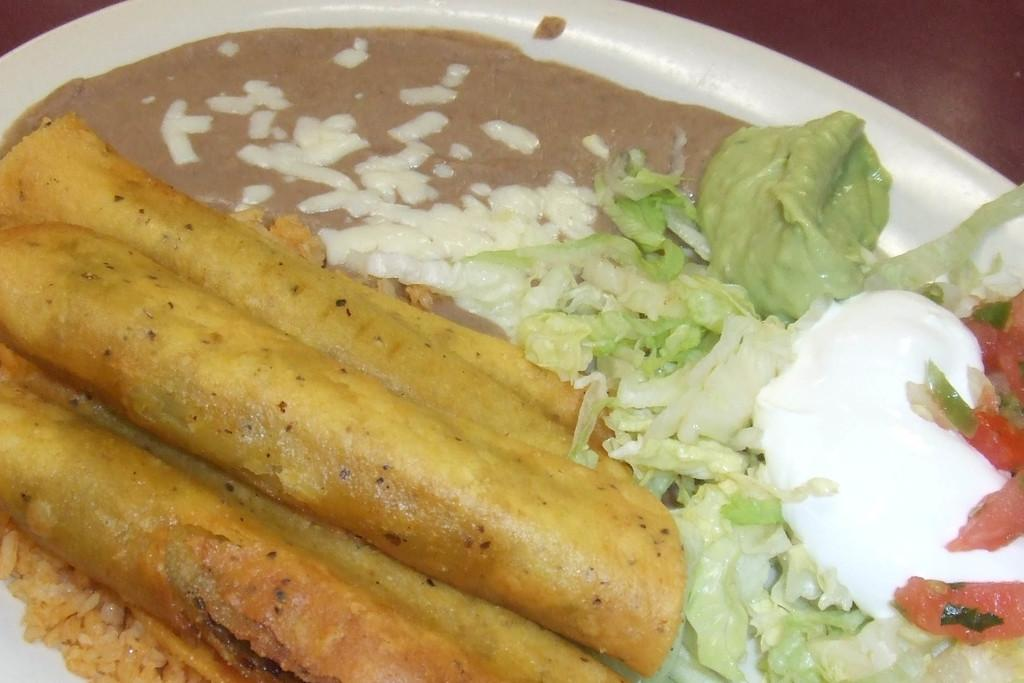What color is the plate that is visible in the image? There is a white color plate in the image. What type of food is on the plate? There is breakfast food, salads, and curry on the plate. What type of business is being conducted on the plate? There is no business being conducted on the plate; it is a plate with food on it. What type of jeans are visible on the plate? There are no jeans present on the plate; it is a plate with food on it. 